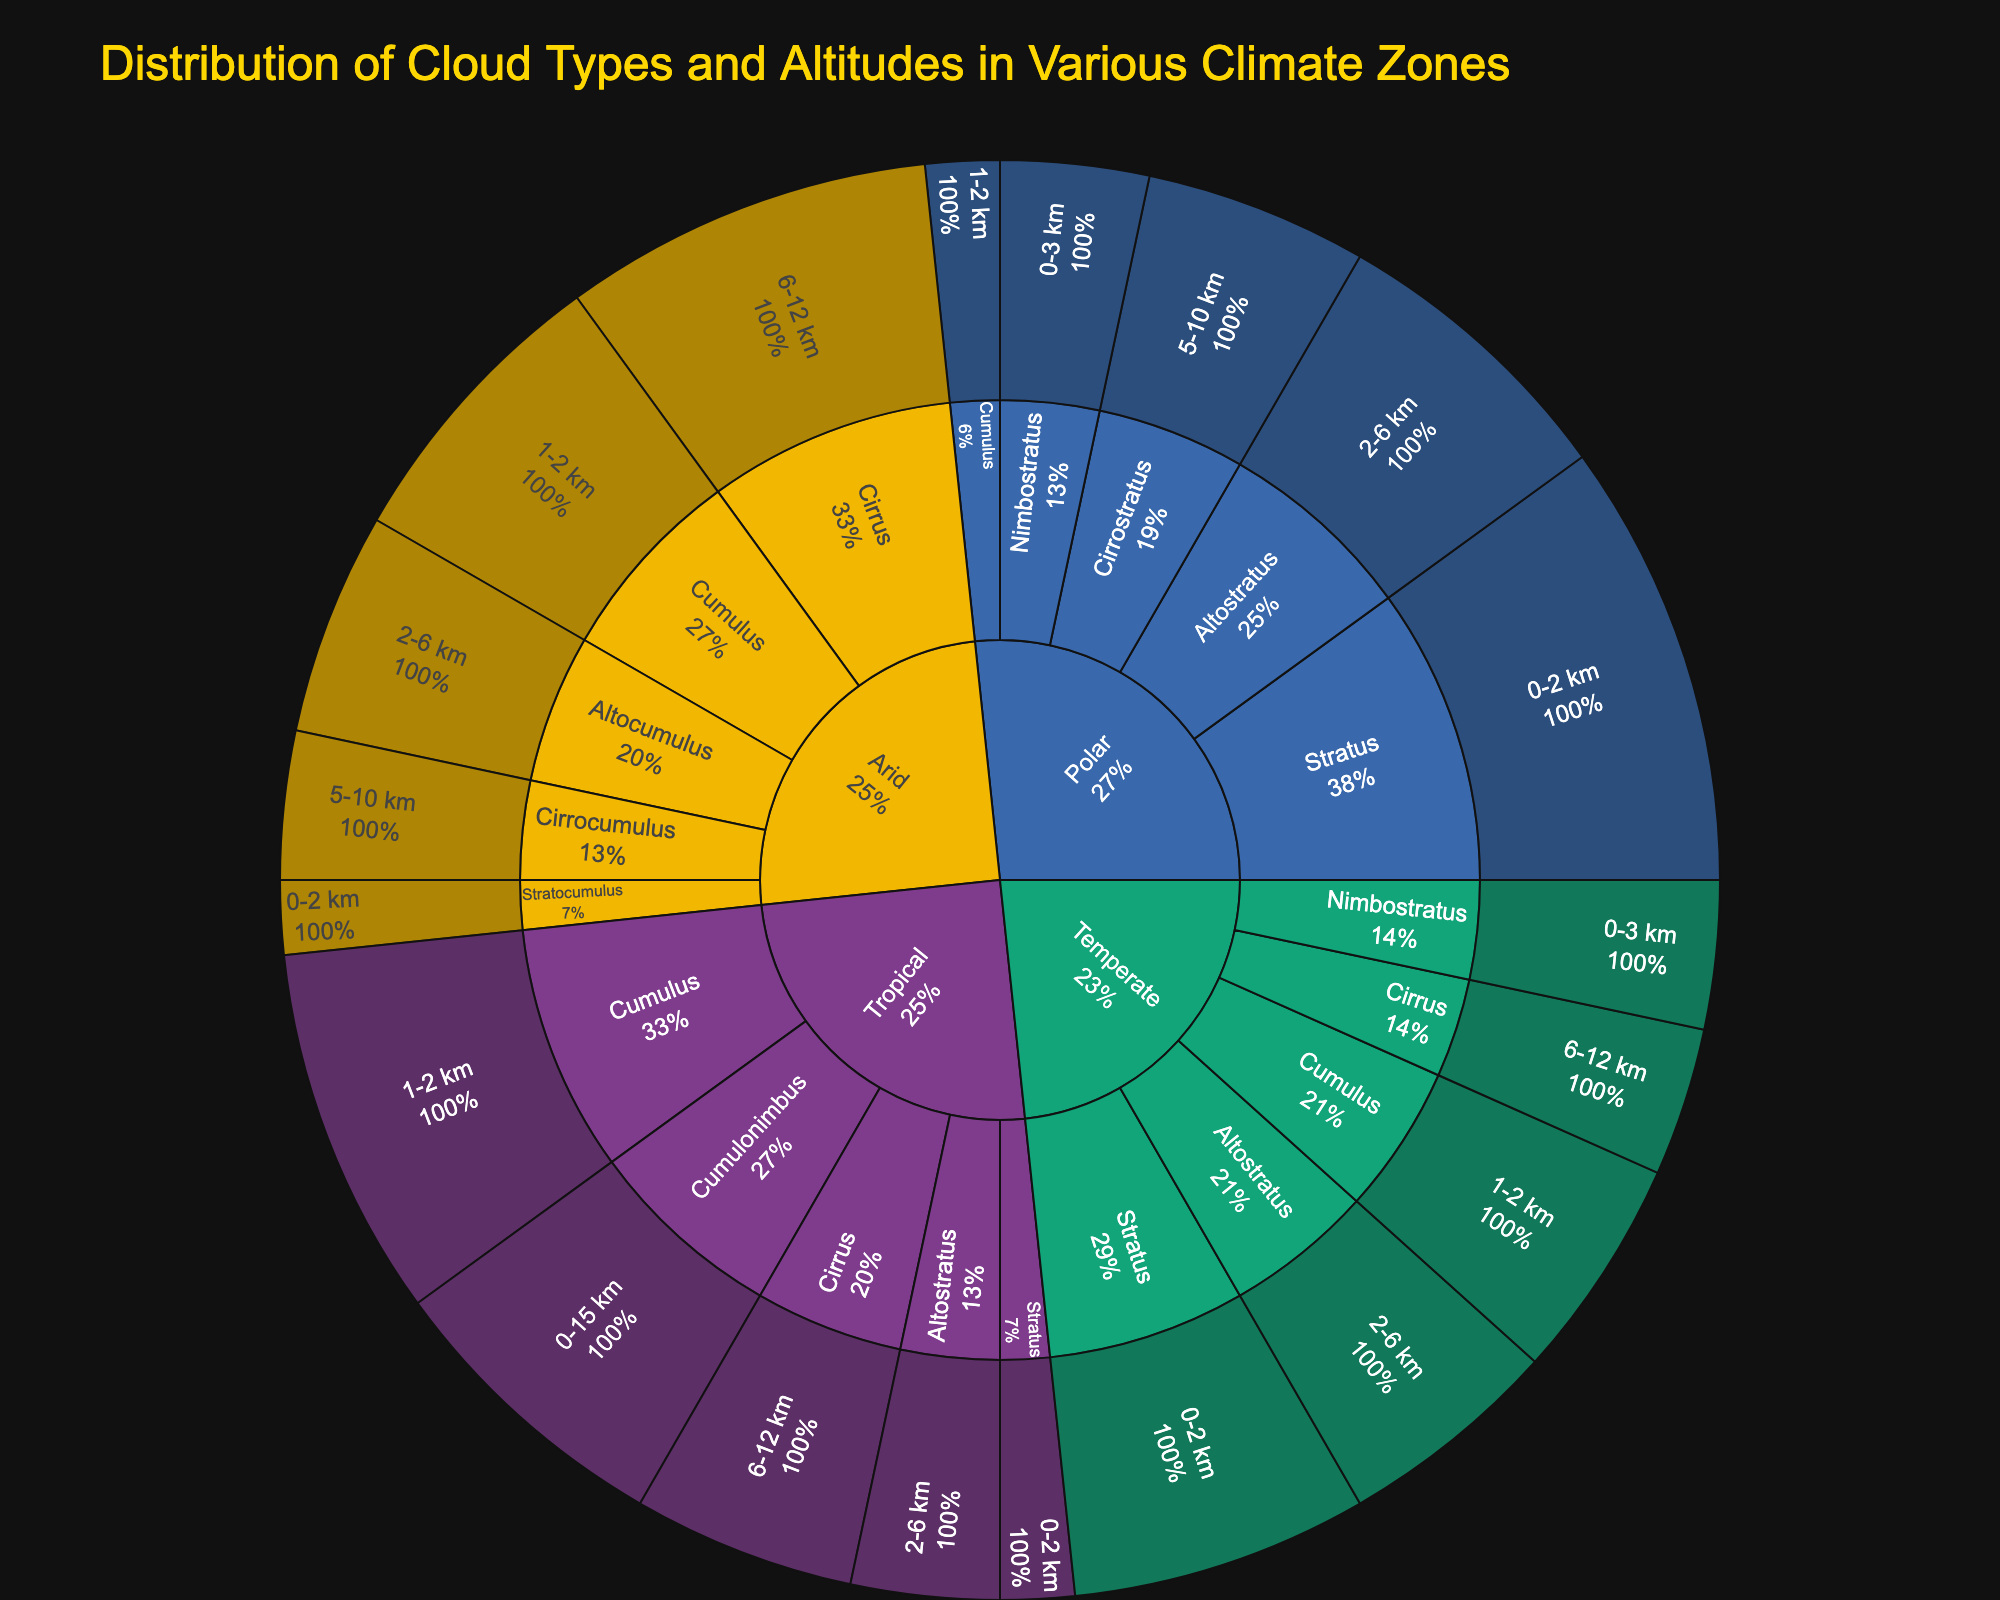What is the title of the sunburst plot? The title is prominently displayed at the top of the plot, serving to inform viewers about the context of the data presented.
Answer: Distribution of Cloud Types and Altitudes in Various Climate Zones Which cloud type has the highest percentage in the Polar climate zone? The Polar climate zone can be identified in the outer layer of the sunburst plot. By examining the segments branching from it, we see that Stratus has the highest percentage.
Answer: Stratus What is the percentage of Cirrus clouds in the Tropical climate zone? By navigating from the Tropical section to Cirrus within the sunburst plot, the percentage is displayed in the hover data or the segment itself.
Answer: 15% Which cloud type appears uniquely in the Arid climate zone? By examining the cloud types for Arid and comparing them with those in other climates, Cirrocumulus is unique since it appears only in Arid but not in Tropical, Temperate, or Polar.
Answer: Cirrocumulus Compare the percentage of Cumulus clouds between the Tropical and Temperate climate zones. Locate the Cumulus segments within both the Tropical and Temperate zones and compare the percentages. Tropical Cumulus is 25% while Temperate Cumulus is 15%.
Answer: 25% vs 15% What is the total percentage of Stratus clouds across all climate zones? Summing the percentages of Stratus in Tropical (5%), Temperate (20%), and Polar (30%) gives 5 + 20 + 30 = 55%.
Answer: 55% Identify the altitude range with the highest cumulative percentage of cloud types in the Temperate climate zone. In the Temperate zone, sum the percentages within each altitude range: 0-2 km (Stratus 20% + Nimbostratus 10% = 30%), 1-2 km (Cumulus 15%), 2-6 km (Altostratus 15%), 6-12 km (Cirrus 10%). The range 0-2 km has the highest cumulative percentage of 30%.
Answer: 0-2 km What percentage of cloud types in the Arid climate zone belong to an altitude range of 6-12 km? By checking the Arid segments with altitude range 6-12 km (Cirrus only), sum the percentage: Cirrus (25%).
Answer: 25% How do Cirrostratus clouds in the Polar climate zone compare percentage-wise to Cirrus clouds in the Temperate climate zone? Find the Cirrostratus percentage in Polar (15%) and Cirrus percentage in Temperate (10%), then compare. Cirrostratus in Polar is 5% higher than Cirrus in Temperate.
Answer: 5% higher in Polar Which cloud type in the Temperate climate zone has the smallest percentage, and what is it? Examine the segments within the Temperate zone to identify the one with the smallest percentage. Nimbostratus and Cirrus both have 10%.
Answer: Nimbostratus and Cirrus 